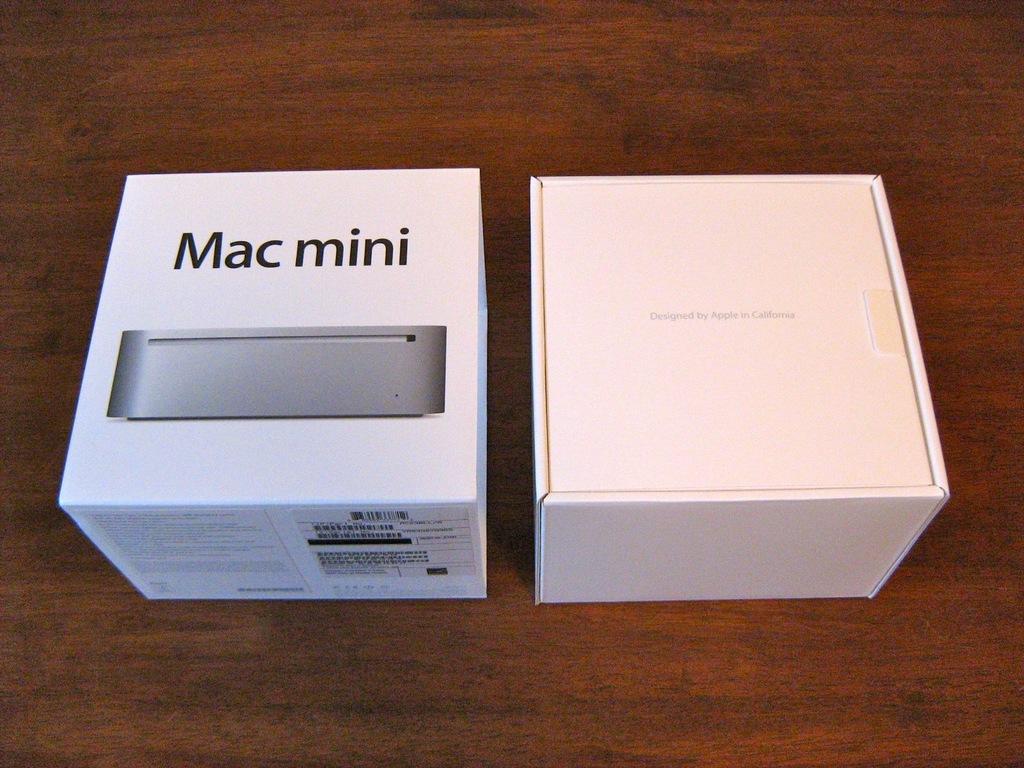What type of item is this?
Your response must be concise. Mac mini. 